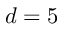<formula> <loc_0><loc_0><loc_500><loc_500>d = 5</formula> 